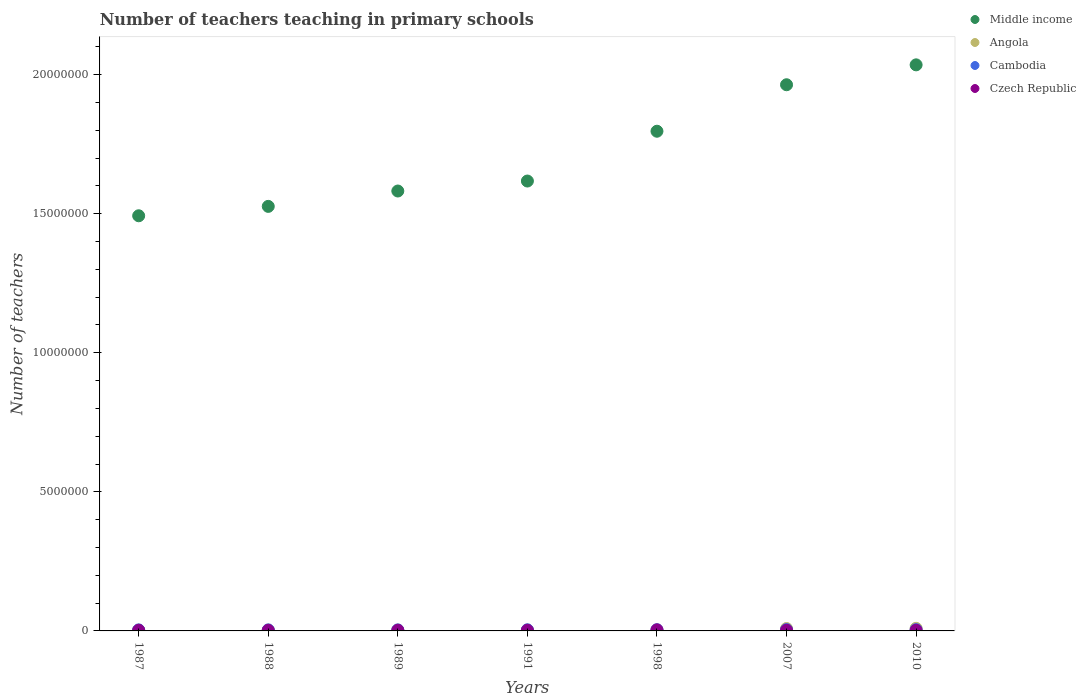How many different coloured dotlines are there?
Your response must be concise. 4. Is the number of dotlines equal to the number of legend labels?
Offer a very short reply. Yes. What is the number of teachers teaching in primary schools in Czech Republic in 1988?
Your response must be concise. 2.15e+04. Across all years, what is the maximum number of teachers teaching in primary schools in Middle income?
Give a very brief answer. 2.04e+07. Across all years, what is the minimum number of teachers teaching in primary schools in Czech Republic?
Keep it short and to the point. 2.15e+04. In which year was the number of teachers teaching in primary schools in Angola maximum?
Your answer should be compact. 2010. What is the total number of teachers teaching in primary schools in Czech Republic in the graph?
Provide a succinct answer. 1.78e+05. What is the difference between the number of teachers teaching in primary schools in Cambodia in 1989 and that in 2010?
Your response must be concise. -9975. What is the difference between the number of teachers teaching in primary schools in Middle income in 1998 and the number of teachers teaching in primary schools in Cambodia in 1988?
Offer a very short reply. 1.79e+07. What is the average number of teachers teaching in primary schools in Middle income per year?
Make the answer very short. 1.72e+07. In the year 1998, what is the difference between the number of teachers teaching in primary schools in Czech Republic and number of teachers teaching in primary schools in Angola?
Provide a succinct answer. 5618. In how many years, is the number of teachers teaching in primary schools in Middle income greater than 7000000?
Your answer should be very brief. 7. What is the ratio of the number of teachers teaching in primary schools in Cambodia in 1991 to that in 2007?
Offer a very short reply. 0.84. Is the number of teachers teaching in primary schools in Czech Republic in 1989 less than that in 1991?
Offer a terse response. Yes. What is the difference between the highest and the second highest number of teachers teaching in primary schools in Angola?
Give a very brief answer. 6965. What is the difference between the highest and the lowest number of teachers teaching in primary schools in Czech Republic?
Provide a succinct answer. 1.60e+04. In how many years, is the number of teachers teaching in primary schools in Cambodia greater than the average number of teachers teaching in primary schools in Cambodia taken over all years?
Offer a very short reply. 3. Is the sum of the number of teachers teaching in primary schools in Cambodia in 1989 and 1998 greater than the maximum number of teachers teaching in primary schools in Middle income across all years?
Provide a succinct answer. No. Is it the case that in every year, the sum of the number of teachers teaching in primary schools in Czech Republic and number of teachers teaching in primary schools in Cambodia  is greater than the sum of number of teachers teaching in primary schools in Middle income and number of teachers teaching in primary schools in Angola?
Your answer should be compact. No. How many dotlines are there?
Keep it short and to the point. 4. Are the values on the major ticks of Y-axis written in scientific E-notation?
Your answer should be compact. No. Does the graph contain any zero values?
Offer a very short reply. No. Does the graph contain grids?
Offer a terse response. No. Where does the legend appear in the graph?
Offer a terse response. Top right. How many legend labels are there?
Offer a very short reply. 4. How are the legend labels stacked?
Your response must be concise. Vertical. What is the title of the graph?
Make the answer very short. Number of teachers teaching in primary schools. What is the label or title of the Y-axis?
Offer a very short reply. Number of teachers. What is the Number of teachers in Middle income in 1987?
Offer a terse response. 1.49e+07. What is the Number of teachers in Angola in 1987?
Give a very brief answer. 3.03e+04. What is the Number of teachers of Cambodia in 1987?
Your answer should be compact. 3.68e+04. What is the Number of teachers of Czech Republic in 1987?
Your response must be concise. 2.27e+04. What is the Number of teachers in Middle income in 1988?
Give a very brief answer. 1.53e+07. What is the Number of teachers of Angola in 1988?
Your answer should be compact. 3.17e+04. What is the Number of teachers of Cambodia in 1988?
Offer a terse response. 3.73e+04. What is the Number of teachers in Czech Republic in 1988?
Offer a very short reply. 2.15e+04. What is the Number of teachers of Middle income in 1989?
Make the answer very short. 1.58e+07. What is the Number of teachers of Angola in 1989?
Your response must be concise. 3.20e+04. What is the Number of teachers of Cambodia in 1989?
Offer a very short reply. 3.69e+04. What is the Number of teachers in Czech Republic in 1989?
Give a very brief answer. 2.34e+04. What is the Number of teachers of Middle income in 1991?
Ensure brevity in your answer.  1.62e+07. What is the Number of teachers of Angola in 1991?
Your answer should be compact. 3.11e+04. What is the Number of teachers in Cambodia in 1991?
Your response must be concise. 4.08e+04. What is the Number of teachers of Czech Republic in 1991?
Provide a short and direct response. 2.36e+04. What is the Number of teachers in Middle income in 1998?
Offer a very short reply. 1.80e+07. What is the Number of teachers in Angola in 1998?
Give a very brief answer. 3.19e+04. What is the Number of teachers of Cambodia in 1998?
Your answer should be compact. 4.33e+04. What is the Number of teachers in Czech Republic in 1998?
Your answer should be compact. 3.75e+04. What is the Number of teachers of Middle income in 2007?
Ensure brevity in your answer.  1.96e+07. What is the Number of teachers in Angola in 2007?
Your answer should be compact. 8.68e+04. What is the Number of teachers of Cambodia in 2007?
Provide a short and direct response. 4.87e+04. What is the Number of teachers of Czech Republic in 2007?
Offer a very short reply. 2.47e+04. What is the Number of teachers of Middle income in 2010?
Provide a short and direct response. 2.04e+07. What is the Number of teachers in Angola in 2010?
Offer a very short reply. 9.37e+04. What is the Number of teachers in Cambodia in 2010?
Offer a very short reply. 4.69e+04. What is the Number of teachers of Czech Republic in 2010?
Ensure brevity in your answer.  2.48e+04. Across all years, what is the maximum Number of teachers of Middle income?
Provide a succinct answer. 2.04e+07. Across all years, what is the maximum Number of teachers of Angola?
Your response must be concise. 9.37e+04. Across all years, what is the maximum Number of teachers in Cambodia?
Offer a terse response. 4.87e+04. Across all years, what is the maximum Number of teachers in Czech Republic?
Provide a short and direct response. 3.75e+04. Across all years, what is the minimum Number of teachers of Middle income?
Make the answer very short. 1.49e+07. Across all years, what is the minimum Number of teachers in Angola?
Make the answer very short. 3.03e+04. Across all years, what is the minimum Number of teachers of Cambodia?
Your answer should be compact. 3.68e+04. Across all years, what is the minimum Number of teachers of Czech Republic?
Provide a succinct answer. 2.15e+04. What is the total Number of teachers of Middle income in the graph?
Make the answer very short. 1.20e+08. What is the total Number of teachers in Angola in the graph?
Provide a short and direct response. 3.37e+05. What is the total Number of teachers of Cambodia in the graph?
Offer a very short reply. 2.91e+05. What is the total Number of teachers of Czech Republic in the graph?
Provide a short and direct response. 1.78e+05. What is the difference between the Number of teachers in Middle income in 1987 and that in 1988?
Provide a succinct answer. -3.38e+05. What is the difference between the Number of teachers in Angola in 1987 and that in 1988?
Offer a very short reply. -1348. What is the difference between the Number of teachers of Cambodia in 1987 and that in 1988?
Provide a short and direct response. -538. What is the difference between the Number of teachers in Czech Republic in 1987 and that in 1988?
Offer a very short reply. 1203. What is the difference between the Number of teachers of Middle income in 1987 and that in 1989?
Offer a very short reply. -8.90e+05. What is the difference between the Number of teachers of Angola in 1987 and that in 1989?
Give a very brief answer. -1643. What is the difference between the Number of teachers in Cambodia in 1987 and that in 1989?
Your answer should be very brief. -176. What is the difference between the Number of teachers of Czech Republic in 1987 and that in 1989?
Ensure brevity in your answer.  -643. What is the difference between the Number of teachers of Middle income in 1987 and that in 1991?
Keep it short and to the point. -1.25e+06. What is the difference between the Number of teachers of Angola in 1987 and that in 1991?
Offer a terse response. -752. What is the difference between the Number of teachers in Cambodia in 1987 and that in 1991?
Offer a very short reply. -4066. What is the difference between the Number of teachers in Czech Republic in 1987 and that in 1991?
Offer a very short reply. -888. What is the difference between the Number of teachers of Middle income in 1987 and that in 1998?
Your answer should be very brief. -3.04e+06. What is the difference between the Number of teachers of Angola in 1987 and that in 1998?
Offer a terse response. -1568. What is the difference between the Number of teachers in Cambodia in 1987 and that in 1998?
Provide a short and direct response. -6528. What is the difference between the Number of teachers in Czech Republic in 1987 and that in 1998?
Provide a short and direct response. -1.48e+04. What is the difference between the Number of teachers of Middle income in 1987 and that in 2007?
Make the answer very short. -4.71e+06. What is the difference between the Number of teachers of Angola in 1987 and that in 2007?
Your answer should be compact. -5.65e+04. What is the difference between the Number of teachers of Cambodia in 1987 and that in 2007?
Offer a terse response. -1.20e+04. What is the difference between the Number of teachers of Czech Republic in 1987 and that in 2007?
Give a very brief answer. -1971. What is the difference between the Number of teachers in Middle income in 1987 and that in 2010?
Provide a succinct answer. -5.43e+06. What is the difference between the Number of teachers of Angola in 1987 and that in 2010?
Ensure brevity in your answer.  -6.34e+04. What is the difference between the Number of teachers of Cambodia in 1987 and that in 2010?
Your response must be concise. -1.02e+04. What is the difference between the Number of teachers in Czech Republic in 1987 and that in 2010?
Your answer should be very brief. -2027. What is the difference between the Number of teachers in Middle income in 1988 and that in 1989?
Offer a terse response. -5.53e+05. What is the difference between the Number of teachers in Angola in 1988 and that in 1989?
Ensure brevity in your answer.  -295. What is the difference between the Number of teachers of Cambodia in 1988 and that in 1989?
Offer a very short reply. 362. What is the difference between the Number of teachers of Czech Republic in 1988 and that in 1989?
Give a very brief answer. -1846. What is the difference between the Number of teachers of Middle income in 1988 and that in 1991?
Provide a succinct answer. -9.12e+05. What is the difference between the Number of teachers in Angola in 1988 and that in 1991?
Offer a very short reply. 596. What is the difference between the Number of teachers of Cambodia in 1988 and that in 1991?
Give a very brief answer. -3528. What is the difference between the Number of teachers in Czech Republic in 1988 and that in 1991?
Your answer should be compact. -2091. What is the difference between the Number of teachers in Middle income in 1988 and that in 1998?
Your response must be concise. -2.70e+06. What is the difference between the Number of teachers of Angola in 1988 and that in 1998?
Make the answer very short. -220. What is the difference between the Number of teachers of Cambodia in 1988 and that in 1998?
Keep it short and to the point. -5990. What is the difference between the Number of teachers of Czech Republic in 1988 and that in 1998?
Keep it short and to the point. -1.60e+04. What is the difference between the Number of teachers of Middle income in 1988 and that in 2007?
Keep it short and to the point. -4.37e+06. What is the difference between the Number of teachers in Angola in 1988 and that in 2007?
Your response must be concise. -5.51e+04. What is the difference between the Number of teachers in Cambodia in 1988 and that in 2007?
Your answer should be very brief. -1.14e+04. What is the difference between the Number of teachers of Czech Republic in 1988 and that in 2007?
Offer a terse response. -3174. What is the difference between the Number of teachers in Middle income in 1988 and that in 2010?
Keep it short and to the point. -5.09e+06. What is the difference between the Number of teachers in Angola in 1988 and that in 2010?
Your response must be concise. -6.21e+04. What is the difference between the Number of teachers of Cambodia in 1988 and that in 2010?
Ensure brevity in your answer.  -9613. What is the difference between the Number of teachers in Czech Republic in 1988 and that in 2010?
Make the answer very short. -3230. What is the difference between the Number of teachers of Middle income in 1989 and that in 1991?
Provide a succinct answer. -3.59e+05. What is the difference between the Number of teachers of Angola in 1989 and that in 1991?
Keep it short and to the point. 891. What is the difference between the Number of teachers of Cambodia in 1989 and that in 1991?
Keep it short and to the point. -3890. What is the difference between the Number of teachers of Czech Republic in 1989 and that in 1991?
Your answer should be compact. -245. What is the difference between the Number of teachers of Middle income in 1989 and that in 1998?
Provide a succinct answer. -2.15e+06. What is the difference between the Number of teachers of Angola in 1989 and that in 1998?
Keep it short and to the point. 75. What is the difference between the Number of teachers of Cambodia in 1989 and that in 1998?
Keep it short and to the point. -6352. What is the difference between the Number of teachers of Czech Republic in 1989 and that in 1998?
Offer a very short reply. -1.41e+04. What is the difference between the Number of teachers of Middle income in 1989 and that in 2007?
Offer a very short reply. -3.82e+06. What is the difference between the Number of teachers in Angola in 1989 and that in 2007?
Give a very brief answer. -5.48e+04. What is the difference between the Number of teachers of Cambodia in 1989 and that in 2007?
Provide a short and direct response. -1.18e+04. What is the difference between the Number of teachers of Czech Republic in 1989 and that in 2007?
Offer a very short reply. -1328. What is the difference between the Number of teachers in Middle income in 1989 and that in 2010?
Give a very brief answer. -4.54e+06. What is the difference between the Number of teachers of Angola in 1989 and that in 2010?
Your answer should be compact. -6.18e+04. What is the difference between the Number of teachers of Cambodia in 1989 and that in 2010?
Ensure brevity in your answer.  -9975. What is the difference between the Number of teachers of Czech Republic in 1989 and that in 2010?
Keep it short and to the point. -1384. What is the difference between the Number of teachers in Middle income in 1991 and that in 1998?
Provide a succinct answer. -1.79e+06. What is the difference between the Number of teachers in Angola in 1991 and that in 1998?
Give a very brief answer. -816. What is the difference between the Number of teachers in Cambodia in 1991 and that in 1998?
Your answer should be compact. -2462. What is the difference between the Number of teachers in Czech Republic in 1991 and that in 1998?
Your answer should be very brief. -1.39e+04. What is the difference between the Number of teachers in Middle income in 1991 and that in 2007?
Your answer should be compact. -3.46e+06. What is the difference between the Number of teachers in Angola in 1991 and that in 2007?
Your answer should be very brief. -5.57e+04. What is the difference between the Number of teachers in Cambodia in 1991 and that in 2007?
Ensure brevity in your answer.  -7916. What is the difference between the Number of teachers in Czech Republic in 1991 and that in 2007?
Your answer should be very brief. -1083. What is the difference between the Number of teachers of Middle income in 1991 and that in 2010?
Ensure brevity in your answer.  -4.18e+06. What is the difference between the Number of teachers in Angola in 1991 and that in 2010?
Your response must be concise. -6.27e+04. What is the difference between the Number of teachers of Cambodia in 1991 and that in 2010?
Your response must be concise. -6085. What is the difference between the Number of teachers of Czech Republic in 1991 and that in 2010?
Your answer should be very brief. -1139. What is the difference between the Number of teachers in Middle income in 1998 and that in 2007?
Your answer should be compact. -1.67e+06. What is the difference between the Number of teachers of Angola in 1998 and that in 2007?
Offer a very short reply. -5.49e+04. What is the difference between the Number of teachers in Cambodia in 1998 and that in 2007?
Make the answer very short. -5454. What is the difference between the Number of teachers of Czech Republic in 1998 and that in 2007?
Your response must be concise. 1.28e+04. What is the difference between the Number of teachers of Middle income in 1998 and that in 2010?
Keep it short and to the point. -2.39e+06. What is the difference between the Number of teachers in Angola in 1998 and that in 2010?
Ensure brevity in your answer.  -6.19e+04. What is the difference between the Number of teachers in Cambodia in 1998 and that in 2010?
Provide a succinct answer. -3623. What is the difference between the Number of teachers of Czech Republic in 1998 and that in 2010?
Ensure brevity in your answer.  1.27e+04. What is the difference between the Number of teachers of Middle income in 2007 and that in 2010?
Ensure brevity in your answer.  -7.15e+05. What is the difference between the Number of teachers in Angola in 2007 and that in 2010?
Provide a short and direct response. -6965. What is the difference between the Number of teachers of Cambodia in 2007 and that in 2010?
Your answer should be very brief. 1831. What is the difference between the Number of teachers in Czech Republic in 2007 and that in 2010?
Provide a succinct answer. -56. What is the difference between the Number of teachers in Middle income in 1987 and the Number of teachers in Angola in 1988?
Your answer should be very brief. 1.49e+07. What is the difference between the Number of teachers of Middle income in 1987 and the Number of teachers of Cambodia in 1988?
Give a very brief answer. 1.49e+07. What is the difference between the Number of teachers in Middle income in 1987 and the Number of teachers in Czech Republic in 1988?
Provide a succinct answer. 1.49e+07. What is the difference between the Number of teachers of Angola in 1987 and the Number of teachers of Cambodia in 1988?
Your answer should be compact. -6982. What is the difference between the Number of teachers of Angola in 1987 and the Number of teachers of Czech Republic in 1988?
Provide a short and direct response. 8771. What is the difference between the Number of teachers in Cambodia in 1987 and the Number of teachers in Czech Republic in 1988?
Offer a terse response. 1.52e+04. What is the difference between the Number of teachers of Middle income in 1987 and the Number of teachers of Angola in 1989?
Provide a short and direct response. 1.49e+07. What is the difference between the Number of teachers of Middle income in 1987 and the Number of teachers of Cambodia in 1989?
Your answer should be compact. 1.49e+07. What is the difference between the Number of teachers of Middle income in 1987 and the Number of teachers of Czech Republic in 1989?
Your answer should be compact. 1.49e+07. What is the difference between the Number of teachers of Angola in 1987 and the Number of teachers of Cambodia in 1989?
Your response must be concise. -6620. What is the difference between the Number of teachers of Angola in 1987 and the Number of teachers of Czech Republic in 1989?
Keep it short and to the point. 6925. What is the difference between the Number of teachers in Cambodia in 1987 and the Number of teachers in Czech Republic in 1989?
Offer a terse response. 1.34e+04. What is the difference between the Number of teachers of Middle income in 1987 and the Number of teachers of Angola in 1991?
Make the answer very short. 1.49e+07. What is the difference between the Number of teachers in Middle income in 1987 and the Number of teachers in Cambodia in 1991?
Provide a succinct answer. 1.49e+07. What is the difference between the Number of teachers of Middle income in 1987 and the Number of teachers of Czech Republic in 1991?
Provide a succinct answer. 1.49e+07. What is the difference between the Number of teachers of Angola in 1987 and the Number of teachers of Cambodia in 1991?
Your answer should be compact. -1.05e+04. What is the difference between the Number of teachers in Angola in 1987 and the Number of teachers in Czech Republic in 1991?
Ensure brevity in your answer.  6680. What is the difference between the Number of teachers in Cambodia in 1987 and the Number of teachers in Czech Republic in 1991?
Offer a terse response. 1.31e+04. What is the difference between the Number of teachers of Middle income in 1987 and the Number of teachers of Angola in 1998?
Your answer should be compact. 1.49e+07. What is the difference between the Number of teachers in Middle income in 1987 and the Number of teachers in Cambodia in 1998?
Provide a succinct answer. 1.49e+07. What is the difference between the Number of teachers of Middle income in 1987 and the Number of teachers of Czech Republic in 1998?
Your answer should be very brief. 1.49e+07. What is the difference between the Number of teachers in Angola in 1987 and the Number of teachers in Cambodia in 1998?
Provide a short and direct response. -1.30e+04. What is the difference between the Number of teachers of Angola in 1987 and the Number of teachers of Czech Republic in 1998?
Ensure brevity in your answer.  -7186. What is the difference between the Number of teachers in Cambodia in 1987 and the Number of teachers in Czech Republic in 1998?
Give a very brief answer. -742. What is the difference between the Number of teachers of Middle income in 1987 and the Number of teachers of Angola in 2007?
Your answer should be compact. 1.48e+07. What is the difference between the Number of teachers in Middle income in 1987 and the Number of teachers in Cambodia in 2007?
Ensure brevity in your answer.  1.49e+07. What is the difference between the Number of teachers in Middle income in 1987 and the Number of teachers in Czech Republic in 2007?
Keep it short and to the point. 1.49e+07. What is the difference between the Number of teachers in Angola in 1987 and the Number of teachers in Cambodia in 2007?
Provide a short and direct response. -1.84e+04. What is the difference between the Number of teachers of Angola in 1987 and the Number of teachers of Czech Republic in 2007?
Offer a terse response. 5597. What is the difference between the Number of teachers in Cambodia in 1987 and the Number of teachers in Czech Republic in 2007?
Provide a succinct answer. 1.20e+04. What is the difference between the Number of teachers in Middle income in 1987 and the Number of teachers in Angola in 2010?
Offer a very short reply. 1.48e+07. What is the difference between the Number of teachers in Middle income in 1987 and the Number of teachers in Cambodia in 2010?
Give a very brief answer. 1.49e+07. What is the difference between the Number of teachers in Middle income in 1987 and the Number of teachers in Czech Republic in 2010?
Make the answer very short. 1.49e+07. What is the difference between the Number of teachers in Angola in 1987 and the Number of teachers in Cambodia in 2010?
Your answer should be very brief. -1.66e+04. What is the difference between the Number of teachers in Angola in 1987 and the Number of teachers in Czech Republic in 2010?
Offer a terse response. 5541. What is the difference between the Number of teachers of Cambodia in 1987 and the Number of teachers of Czech Republic in 2010?
Make the answer very short. 1.20e+04. What is the difference between the Number of teachers of Middle income in 1988 and the Number of teachers of Angola in 1989?
Offer a terse response. 1.52e+07. What is the difference between the Number of teachers of Middle income in 1988 and the Number of teachers of Cambodia in 1989?
Your answer should be compact. 1.52e+07. What is the difference between the Number of teachers in Middle income in 1988 and the Number of teachers in Czech Republic in 1989?
Your answer should be very brief. 1.52e+07. What is the difference between the Number of teachers in Angola in 1988 and the Number of teachers in Cambodia in 1989?
Your answer should be compact. -5272. What is the difference between the Number of teachers in Angola in 1988 and the Number of teachers in Czech Republic in 1989?
Your response must be concise. 8273. What is the difference between the Number of teachers of Cambodia in 1988 and the Number of teachers of Czech Republic in 1989?
Your response must be concise. 1.39e+04. What is the difference between the Number of teachers in Middle income in 1988 and the Number of teachers in Angola in 1991?
Keep it short and to the point. 1.52e+07. What is the difference between the Number of teachers of Middle income in 1988 and the Number of teachers of Cambodia in 1991?
Offer a terse response. 1.52e+07. What is the difference between the Number of teachers in Middle income in 1988 and the Number of teachers in Czech Republic in 1991?
Give a very brief answer. 1.52e+07. What is the difference between the Number of teachers of Angola in 1988 and the Number of teachers of Cambodia in 1991?
Make the answer very short. -9162. What is the difference between the Number of teachers of Angola in 1988 and the Number of teachers of Czech Republic in 1991?
Offer a terse response. 8028. What is the difference between the Number of teachers in Cambodia in 1988 and the Number of teachers in Czech Republic in 1991?
Keep it short and to the point. 1.37e+04. What is the difference between the Number of teachers in Middle income in 1988 and the Number of teachers in Angola in 1998?
Your answer should be very brief. 1.52e+07. What is the difference between the Number of teachers in Middle income in 1988 and the Number of teachers in Cambodia in 1998?
Your answer should be very brief. 1.52e+07. What is the difference between the Number of teachers of Middle income in 1988 and the Number of teachers of Czech Republic in 1998?
Provide a succinct answer. 1.52e+07. What is the difference between the Number of teachers of Angola in 1988 and the Number of teachers of Cambodia in 1998?
Your answer should be very brief. -1.16e+04. What is the difference between the Number of teachers of Angola in 1988 and the Number of teachers of Czech Republic in 1998?
Ensure brevity in your answer.  -5838. What is the difference between the Number of teachers of Cambodia in 1988 and the Number of teachers of Czech Republic in 1998?
Ensure brevity in your answer.  -204. What is the difference between the Number of teachers of Middle income in 1988 and the Number of teachers of Angola in 2007?
Provide a succinct answer. 1.52e+07. What is the difference between the Number of teachers of Middle income in 1988 and the Number of teachers of Cambodia in 2007?
Keep it short and to the point. 1.52e+07. What is the difference between the Number of teachers of Middle income in 1988 and the Number of teachers of Czech Republic in 2007?
Your answer should be compact. 1.52e+07. What is the difference between the Number of teachers of Angola in 1988 and the Number of teachers of Cambodia in 2007?
Give a very brief answer. -1.71e+04. What is the difference between the Number of teachers in Angola in 1988 and the Number of teachers in Czech Republic in 2007?
Your answer should be very brief. 6945. What is the difference between the Number of teachers of Cambodia in 1988 and the Number of teachers of Czech Republic in 2007?
Provide a short and direct response. 1.26e+04. What is the difference between the Number of teachers in Middle income in 1988 and the Number of teachers in Angola in 2010?
Your response must be concise. 1.52e+07. What is the difference between the Number of teachers of Middle income in 1988 and the Number of teachers of Cambodia in 2010?
Your answer should be compact. 1.52e+07. What is the difference between the Number of teachers of Middle income in 1988 and the Number of teachers of Czech Republic in 2010?
Give a very brief answer. 1.52e+07. What is the difference between the Number of teachers in Angola in 1988 and the Number of teachers in Cambodia in 2010?
Provide a succinct answer. -1.52e+04. What is the difference between the Number of teachers in Angola in 1988 and the Number of teachers in Czech Republic in 2010?
Offer a terse response. 6889. What is the difference between the Number of teachers of Cambodia in 1988 and the Number of teachers of Czech Republic in 2010?
Offer a terse response. 1.25e+04. What is the difference between the Number of teachers of Middle income in 1989 and the Number of teachers of Angola in 1991?
Offer a terse response. 1.58e+07. What is the difference between the Number of teachers of Middle income in 1989 and the Number of teachers of Cambodia in 1991?
Provide a short and direct response. 1.58e+07. What is the difference between the Number of teachers of Middle income in 1989 and the Number of teachers of Czech Republic in 1991?
Keep it short and to the point. 1.58e+07. What is the difference between the Number of teachers of Angola in 1989 and the Number of teachers of Cambodia in 1991?
Your response must be concise. -8867. What is the difference between the Number of teachers in Angola in 1989 and the Number of teachers in Czech Republic in 1991?
Offer a terse response. 8323. What is the difference between the Number of teachers in Cambodia in 1989 and the Number of teachers in Czech Republic in 1991?
Offer a terse response. 1.33e+04. What is the difference between the Number of teachers in Middle income in 1989 and the Number of teachers in Angola in 1998?
Provide a succinct answer. 1.58e+07. What is the difference between the Number of teachers in Middle income in 1989 and the Number of teachers in Cambodia in 1998?
Give a very brief answer. 1.58e+07. What is the difference between the Number of teachers in Middle income in 1989 and the Number of teachers in Czech Republic in 1998?
Your response must be concise. 1.58e+07. What is the difference between the Number of teachers of Angola in 1989 and the Number of teachers of Cambodia in 1998?
Keep it short and to the point. -1.13e+04. What is the difference between the Number of teachers of Angola in 1989 and the Number of teachers of Czech Republic in 1998?
Offer a terse response. -5543. What is the difference between the Number of teachers of Cambodia in 1989 and the Number of teachers of Czech Republic in 1998?
Provide a succinct answer. -566. What is the difference between the Number of teachers in Middle income in 1989 and the Number of teachers in Angola in 2007?
Make the answer very short. 1.57e+07. What is the difference between the Number of teachers in Middle income in 1989 and the Number of teachers in Cambodia in 2007?
Offer a very short reply. 1.58e+07. What is the difference between the Number of teachers of Middle income in 1989 and the Number of teachers of Czech Republic in 2007?
Offer a very short reply. 1.58e+07. What is the difference between the Number of teachers of Angola in 1989 and the Number of teachers of Cambodia in 2007?
Ensure brevity in your answer.  -1.68e+04. What is the difference between the Number of teachers of Angola in 1989 and the Number of teachers of Czech Republic in 2007?
Your answer should be very brief. 7240. What is the difference between the Number of teachers in Cambodia in 1989 and the Number of teachers in Czech Republic in 2007?
Keep it short and to the point. 1.22e+04. What is the difference between the Number of teachers in Middle income in 1989 and the Number of teachers in Angola in 2010?
Give a very brief answer. 1.57e+07. What is the difference between the Number of teachers in Middle income in 1989 and the Number of teachers in Cambodia in 2010?
Keep it short and to the point. 1.58e+07. What is the difference between the Number of teachers of Middle income in 1989 and the Number of teachers of Czech Republic in 2010?
Give a very brief answer. 1.58e+07. What is the difference between the Number of teachers in Angola in 1989 and the Number of teachers in Cambodia in 2010?
Offer a terse response. -1.50e+04. What is the difference between the Number of teachers in Angola in 1989 and the Number of teachers in Czech Republic in 2010?
Ensure brevity in your answer.  7184. What is the difference between the Number of teachers in Cambodia in 1989 and the Number of teachers in Czech Republic in 2010?
Offer a terse response. 1.22e+04. What is the difference between the Number of teachers in Middle income in 1991 and the Number of teachers in Angola in 1998?
Offer a terse response. 1.61e+07. What is the difference between the Number of teachers in Middle income in 1991 and the Number of teachers in Cambodia in 1998?
Provide a succinct answer. 1.61e+07. What is the difference between the Number of teachers in Middle income in 1991 and the Number of teachers in Czech Republic in 1998?
Ensure brevity in your answer.  1.61e+07. What is the difference between the Number of teachers of Angola in 1991 and the Number of teachers of Cambodia in 1998?
Your answer should be compact. -1.22e+04. What is the difference between the Number of teachers in Angola in 1991 and the Number of teachers in Czech Republic in 1998?
Offer a very short reply. -6434. What is the difference between the Number of teachers in Cambodia in 1991 and the Number of teachers in Czech Republic in 1998?
Give a very brief answer. 3324. What is the difference between the Number of teachers in Middle income in 1991 and the Number of teachers in Angola in 2007?
Your response must be concise. 1.61e+07. What is the difference between the Number of teachers of Middle income in 1991 and the Number of teachers of Cambodia in 2007?
Make the answer very short. 1.61e+07. What is the difference between the Number of teachers of Middle income in 1991 and the Number of teachers of Czech Republic in 2007?
Provide a short and direct response. 1.61e+07. What is the difference between the Number of teachers of Angola in 1991 and the Number of teachers of Cambodia in 2007?
Keep it short and to the point. -1.77e+04. What is the difference between the Number of teachers of Angola in 1991 and the Number of teachers of Czech Republic in 2007?
Your answer should be compact. 6349. What is the difference between the Number of teachers of Cambodia in 1991 and the Number of teachers of Czech Republic in 2007?
Provide a succinct answer. 1.61e+04. What is the difference between the Number of teachers in Middle income in 1991 and the Number of teachers in Angola in 2010?
Offer a terse response. 1.61e+07. What is the difference between the Number of teachers of Middle income in 1991 and the Number of teachers of Cambodia in 2010?
Provide a succinct answer. 1.61e+07. What is the difference between the Number of teachers in Middle income in 1991 and the Number of teachers in Czech Republic in 2010?
Provide a short and direct response. 1.61e+07. What is the difference between the Number of teachers in Angola in 1991 and the Number of teachers in Cambodia in 2010?
Give a very brief answer. -1.58e+04. What is the difference between the Number of teachers in Angola in 1991 and the Number of teachers in Czech Republic in 2010?
Give a very brief answer. 6293. What is the difference between the Number of teachers of Cambodia in 1991 and the Number of teachers of Czech Republic in 2010?
Ensure brevity in your answer.  1.61e+04. What is the difference between the Number of teachers in Middle income in 1998 and the Number of teachers in Angola in 2007?
Keep it short and to the point. 1.79e+07. What is the difference between the Number of teachers of Middle income in 1998 and the Number of teachers of Cambodia in 2007?
Offer a terse response. 1.79e+07. What is the difference between the Number of teachers of Middle income in 1998 and the Number of teachers of Czech Republic in 2007?
Give a very brief answer. 1.79e+07. What is the difference between the Number of teachers of Angola in 1998 and the Number of teachers of Cambodia in 2007?
Your response must be concise. -1.69e+04. What is the difference between the Number of teachers of Angola in 1998 and the Number of teachers of Czech Republic in 2007?
Your answer should be very brief. 7165. What is the difference between the Number of teachers in Cambodia in 1998 and the Number of teachers in Czech Republic in 2007?
Offer a very short reply. 1.86e+04. What is the difference between the Number of teachers of Middle income in 1998 and the Number of teachers of Angola in 2010?
Offer a terse response. 1.79e+07. What is the difference between the Number of teachers of Middle income in 1998 and the Number of teachers of Cambodia in 2010?
Ensure brevity in your answer.  1.79e+07. What is the difference between the Number of teachers of Middle income in 1998 and the Number of teachers of Czech Republic in 2010?
Give a very brief answer. 1.79e+07. What is the difference between the Number of teachers of Angola in 1998 and the Number of teachers of Cambodia in 2010?
Offer a very short reply. -1.50e+04. What is the difference between the Number of teachers of Angola in 1998 and the Number of teachers of Czech Republic in 2010?
Ensure brevity in your answer.  7109. What is the difference between the Number of teachers in Cambodia in 1998 and the Number of teachers in Czech Republic in 2010?
Offer a terse response. 1.85e+04. What is the difference between the Number of teachers of Middle income in 2007 and the Number of teachers of Angola in 2010?
Make the answer very short. 1.95e+07. What is the difference between the Number of teachers of Middle income in 2007 and the Number of teachers of Cambodia in 2010?
Ensure brevity in your answer.  1.96e+07. What is the difference between the Number of teachers of Middle income in 2007 and the Number of teachers of Czech Republic in 2010?
Provide a succinct answer. 1.96e+07. What is the difference between the Number of teachers in Angola in 2007 and the Number of teachers in Cambodia in 2010?
Provide a short and direct response. 3.99e+04. What is the difference between the Number of teachers of Angola in 2007 and the Number of teachers of Czech Republic in 2010?
Your answer should be very brief. 6.20e+04. What is the difference between the Number of teachers of Cambodia in 2007 and the Number of teachers of Czech Republic in 2010?
Give a very brief answer. 2.40e+04. What is the average Number of teachers of Middle income per year?
Give a very brief answer. 1.72e+07. What is the average Number of teachers of Angola per year?
Give a very brief answer. 4.82e+04. What is the average Number of teachers in Cambodia per year?
Make the answer very short. 4.15e+04. What is the average Number of teachers in Czech Republic per year?
Ensure brevity in your answer.  2.55e+04. In the year 1987, what is the difference between the Number of teachers of Middle income and Number of teachers of Angola?
Make the answer very short. 1.49e+07. In the year 1987, what is the difference between the Number of teachers in Middle income and Number of teachers in Cambodia?
Your answer should be compact. 1.49e+07. In the year 1987, what is the difference between the Number of teachers of Middle income and Number of teachers of Czech Republic?
Offer a very short reply. 1.49e+07. In the year 1987, what is the difference between the Number of teachers in Angola and Number of teachers in Cambodia?
Your answer should be compact. -6444. In the year 1987, what is the difference between the Number of teachers in Angola and Number of teachers in Czech Republic?
Offer a terse response. 7568. In the year 1987, what is the difference between the Number of teachers in Cambodia and Number of teachers in Czech Republic?
Your answer should be very brief. 1.40e+04. In the year 1988, what is the difference between the Number of teachers in Middle income and Number of teachers in Angola?
Your answer should be very brief. 1.52e+07. In the year 1988, what is the difference between the Number of teachers in Middle income and Number of teachers in Cambodia?
Keep it short and to the point. 1.52e+07. In the year 1988, what is the difference between the Number of teachers of Middle income and Number of teachers of Czech Republic?
Ensure brevity in your answer.  1.52e+07. In the year 1988, what is the difference between the Number of teachers of Angola and Number of teachers of Cambodia?
Offer a very short reply. -5634. In the year 1988, what is the difference between the Number of teachers of Angola and Number of teachers of Czech Republic?
Ensure brevity in your answer.  1.01e+04. In the year 1988, what is the difference between the Number of teachers in Cambodia and Number of teachers in Czech Republic?
Offer a terse response. 1.58e+04. In the year 1989, what is the difference between the Number of teachers of Middle income and Number of teachers of Angola?
Your answer should be compact. 1.58e+07. In the year 1989, what is the difference between the Number of teachers of Middle income and Number of teachers of Cambodia?
Provide a short and direct response. 1.58e+07. In the year 1989, what is the difference between the Number of teachers in Middle income and Number of teachers in Czech Republic?
Provide a short and direct response. 1.58e+07. In the year 1989, what is the difference between the Number of teachers in Angola and Number of teachers in Cambodia?
Give a very brief answer. -4977. In the year 1989, what is the difference between the Number of teachers of Angola and Number of teachers of Czech Republic?
Your response must be concise. 8568. In the year 1989, what is the difference between the Number of teachers in Cambodia and Number of teachers in Czech Republic?
Provide a short and direct response. 1.35e+04. In the year 1991, what is the difference between the Number of teachers in Middle income and Number of teachers in Angola?
Give a very brief answer. 1.61e+07. In the year 1991, what is the difference between the Number of teachers of Middle income and Number of teachers of Cambodia?
Provide a succinct answer. 1.61e+07. In the year 1991, what is the difference between the Number of teachers in Middle income and Number of teachers in Czech Republic?
Your answer should be compact. 1.62e+07. In the year 1991, what is the difference between the Number of teachers of Angola and Number of teachers of Cambodia?
Give a very brief answer. -9758. In the year 1991, what is the difference between the Number of teachers in Angola and Number of teachers in Czech Republic?
Provide a short and direct response. 7432. In the year 1991, what is the difference between the Number of teachers of Cambodia and Number of teachers of Czech Republic?
Give a very brief answer. 1.72e+04. In the year 1998, what is the difference between the Number of teachers of Middle income and Number of teachers of Angola?
Your answer should be very brief. 1.79e+07. In the year 1998, what is the difference between the Number of teachers in Middle income and Number of teachers in Cambodia?
Give a very brief answer. 1.79e+07. In the year 1998, what is the difference between the Number of teachers in Middle income and Number of teachers in Czech Republic?
Ensure brevity in your answer.  1.79e+07. In the year 1998, what is the difference between the Number of teachers of Angola and Number of teachers of Cambodia?
Make the answer very short. -1.14e+04. In the year 1998, what is the difference between the Number of teachers in Angola and Number of teachers in Czech Republic?
Offer a terse response. -5618. In the year 1998, what is the difference between the Number of teachers of Cambodia and Number of teachers of Czech Republic?
Offer a very short reply. 5786. In the year 2007, what is the difference between the Number of teachers in Middle income and Number of teachers in Angola?
Give a very brief answer. 1.95e+07. In the year 2007, what is the difference between the Number of teachers in Middle income and Number of teachers in Cambodia?
Your response must be concise. 1.96e+07. In the year 2007, what is the difference between the Number of teachers of Middle income and Number of teachers of Czech Republic?
Make the answer very short. 1.96e+07. In the year 2007, what is the difference between the Number of teachers of Angola and Number of teachers of Cambodia?
Ensure brevity in your answer.  3.80e+04. In the year 2007, what is the difference between the Number of teachers of Angola and Number of teachers of Czech Republic?
Provide a short and direct response. 6.21e+04. In the year 2007, what is the difference between the Number of teachers in Cambodia and Number of teachers in Czech Republic?
Ensure brevity in your answer.  2.40e+04. In the year 2010, what is the difference between the Number of teachers in Middle income and Number of teachers in Angola?
Provide a short and direct response. 2.03e+07. In the year 2010, what is the difference between the Number of teachers of Middle income and Number of teachers of Cambodia?
Offer a terse response. 2.03e+07. In the year 2010, what is the difference between the Number of teachers of Middle income and Number of teachers of Czech Republic?
Offer a very short reply. 2.03e+07. In the year 2010, what is the difference between the Number of teachers in Angola and Number of teachers in Cambodia?
Your answer should be very brief. 4.68e+04. In the year 2010, what is the difference between the Number of teachers in Angola and Number of teachers in Czech Republic?
Your response must be concise. 6.90e+04. In the year 2010, what is the difference between the Number of teachers in Cambodia and Number of teachers in Czech Republic?
Provide a short and direct response. 2.21e+04. What is the ratio of the Number of teachers in Middle income in 1987 to that in 1988?
Make the answer very short. 0.98. What is the ratio of the Number of teachers of Angola in 1987 to that in 1988?
Keep it short and to the point. 0.96. What is the ratio of the Number of teachers of Cambodia in 1987 to that in 1988?
Keep it short and to the point. 0.99. What is the ratio of the Number of teachers in Czech Republic in 1987 to that in 1988?
Provide a succinct answer. 1.06. What is the ratio of the Number of teachers in Middle income in 1987 to that in 1989?
Keep it short and to the point. 0.94. What is the ratio of the Number of teachers in Angola in 1987 to that in 1989?
Offer a terse response. 0.95. What is the ratio of the Number of teachers in Czech Republic in 1987 to that in 1989?
Provide a succinct answer. 0.97. What is the ratio of the Number of teachers of Middle income in 1987 to that in 1991?
Ensure brevity in your answer.  0.92. What is the ratio of the Number of teachers in Angola in 1987 to that in 1991?
Your response must be concise. 0.98. What is the ratio of the Number of teachers of Cambodia in 1987 to that in 1991?
Provide a short and direct response. 0.9. What is the ratio of the Number of teachers of Czech Republic in 1987 to that in 1991?
Provide a short and direct response. 0.96. What is the ratio of the Number of teachers in Middle income in 1987 to that in 1998?
Provide a short and direct response. 0.83. What is the ratio of the Number of teachers in Angola in 1987 to that in 1998?
Give a very brief answer. 0.95. What is the ratio of the Number of teachers in Cambodia in 1987 to that in 1998?
Offer a terse response. 0.85. What is the ratio of the Number of teachers of Czech Republic in 1987 to that in 1998?
Offer a very short reply. 0.61. What is the ratio of the Number of teachers in Middle income in 1987 to that in 2007?
Offer a very short reply. 0.76. What is the ratio of the Number of teachers in Angola in 1987 to that in 2007?
Keep it short and to the point. 0.35. What is the ratio of the Number of teachers in Cambodia in 1987 to that in 2007?
Your answer should be very brief. 0.75. What is the ratio of the Number of teachers in Czech Republic in 1987 to that in 2007?
Your response must be concise. 0.92. What is the ratio of the Number of teachers of Middle income in 1987 to that in 2010?
Make the answer very short. 0.73. What is the ratio of the Number of teachers of Angola in 1987 to that in 2010?
Your response must be concise. 0.32. What is the ratio of the Number of teachers in Cambodia in 1987 to that in 2010?
Give a very brief answer. 0.78. What is the ratio of the Number of teachers of Czech Republic in 1987 to that in 2010?
Give a very brief answer. 0.92. What is the ratio of the Number of teachers of Middle income in 1988 to that in 1989?
Your answer should be very brief. 0.97. What is the ratio of the Number of teachers in Cambodia in 1988 to that in 1989?
Offer a very short reply. 1.01. What is the ratio of the Number of teachers of Czech Republic in 1988 to that in 1989?
Keep it short and to the point. 0.92. What is the ratio of the Number of teachers in Middle income in 1988 to that in 1991?
Make the answer very short. 0.94. What is the ratio of the Number of teachers in Angola in 1988 to that in 1991?
Ensure brevity in your answer.  1.02. What is the ratio of the Number of teachers of Cambodia in 1988 to that in 1991?
Make the answer very short. 0.91. What is the ratio of the Number of teachers of Czech Republic in 1988 to that in 1991?
Offer a very short reply. 0.91. What is the ratio of the Number of teachers in Middle income in 1988 to that in 1998?
Provide a succinct answer. 0.85. What is the ratio of the Number of teachers in Angola in 1988 to that in 1998?
Provide a succinct answer. 0.99. What is the ratio of the Number of teachers in Cambodia in 1988 to that in 1998?
Provide a succinct answer. 0.86. What is the ratio of the Number of teachers in Czech Republic in 1988 to that in 1998?
Keep it short and to the point. 0.57. What is the ratio of the Number of teachers of Middle income in 1988 to that in 2007?
Your answer should be very brief. 0.78. What is the ratio of the Number of teachers of Angola in 1988 to that in 2007?
Give a very brief answer. 0.36. What is the ratio of the Number of teachers of Cambodia in 1988 to that in 2007?
Ensure brevity in your answer.  0.77. What is the ratio of the Number of teachers of Czech Republic in 1988 to that in 2007?
Your answer should be compact. 0.87. What is the ratio of the Number of teachers in Angola in 1988 to that in 2010?
Offer a terse response. 0.34. What is the ratio of the Number of teachers of Cambodia in 1988 to that in 2010?
Provide a succinct answer. 0.8. What is the ratio of the Number of teachers of Czech Republic in 1988 to that in 2010?
Your response must be concise. 0.87. What is the ratio of the Number of teachers in Middle income in 1989 to that in 1991?
Provide a succinct answer. 0.98. What is the ratio of the Number of teachers of Angola in 1989 to that in 1991?
Your answer should be very brief. 1.03. What is the ratio of the Number of teachers of Cambodia in 1989 to that in 1991?
Provide a succinct answer. 0.9. What is the ratio of the Number of teachers of Middle income in 1989 to that in 1998?
Ensure brevity in your answer.  0.88. What is the ratio of the Number of teachers in Angola in 1989 to that in 1998?
Your response must be concise. 1. What is the ratio of the Number of teachers of Cambodia in 1989 to that in 1998?
Provide a succinct answer. 0.85. What is the ratio of the Number of teachers of Czech Republic in 1989 to that in 1998?
Your response must be concise. 0.62. What is the ratio of the Number of teachers of Middle income in 1989 to that in 2007?
Give a very brief answer. 0.81. What is the ratio of the Number of teachers in Angola in 1989 to that in 2007?
Provide a succinct answer. 0.37. What is the ratio of the Number of teachers of Cambodia in 1989 to that in 2007?
Provide a short and direct response. 0.76. What is the ratio of the Number of teachers in Czech Republic in 1989 to that in 2007?
Provide a short and direct response. 0.95. What is the ratio of the Number of teachers of Middle income in 1989 to that in 2010?
Give a very brief answer. 0.78. What is the ratio of the Number of teachers in Angola in 1989 to that in 2010?
Ensure brevity in your answer.  0.34. What is the ratio of the Number of teachers in Cambodia in 1989 to that in 2010?
Offer a very short reply. 0.79. What is the ratio of the Number of teachers of Czech Republic in 1989 to that in 2010?
Your answer should be very brief. 0.94. What is the ratio of the Number of teachers of Middle income in 1991 to that in 1998?
Provide a succinct answer. 0.9. What is the ratio of the Number of teachers of Angola in 1991 to that in 1998?
Your answer should be very brief. 0.97. What is the ratio of the Number of teachers in Cambodia in 1991 to that in 1998?
Your response must be concise. 0.94. What is the ratio of the Number of teachers of Czech Republic in 1991 to that in 1998?
Your answer should be compact. 0.63. What is the ratio of the Number of teachers in Middle income in 1991 to that in 2007?
Make the answer very short. 0.82. What is the ratio of the Number of teachers in Angola in 1991 to that in 2007?
Keep it short and to the point. 0.36. What is the ratio of the Number of teachers in Cambodia in 1991 to that in 2007?
Provide a succinct answer. 0.84. What is the ratio of the Number of teachers in Czech Republic in 1991 to that in 2007?
Ensure brevity in your answer.  0.96. What is the ratio of the Number of teachers in Middle income in 1991 to that in 2010?
Your answer should be compact. 0.79. What is the ratio of the Number of teachers of Angola in 1991 to that in 2010?
Keep it short and to the point. 0.33. What is the ratio of the Number of teachers in Cambodia in 1991 to that in 2010?
Your answer should be compact. 0.87. What is the ratio of the Number of teachers of Czech Republic in 1991 to that in 2010?
Ensure brevity in your answer.  0.95. What is the ratio of the Number of teachers of Middle income in 1998 to that in 2007?
Make the answer very short. 0.91. What is the ratio of the Number of teachers of Angola in 1998 to that in 2007?
Your response must be concise. 0.37. What is the ratio of the Number of teachers in Cambodia in 1998 to that in 2007?
Provide a short and direct response. 0.89. What is the ratio of the Number of teachers in Czech Republic in 1998 to that in 2007?
Provide a succinct answer. 1.52. What is the ratio of the Number of teachers in Middle income in 1998 to that in 2010?
Make the answer very short. 0.88. What is the ratio of the Number of teachers of Angola in 1998 to that in 2010?
Your response must be concise. 0.34. What is the ratio of the Number of teachers in Cambodia in 1998 to that in 2010?
Provide a succinct answer. 0.92. What is the ratio of the Number of teachers in Czech Republic in 1998 to that in 2010?
Your response must be concise. 1.51. What is the ratio of the Number of teachers in Middle income in 2007 to that in 2010?
Keep it short and to the point. 0.96. What is the ratio of the Number of teachers in Angola in 2007 to that in 2010?
Offer a very short reply. 0.93. What is the ratio of the Number of teachers of Cambodia in 2007 to that in 2010?
Provide a short and direct response. 1.04. What is the difference between the highest and the second highest Number of teachers of Middle income?
Your answer should be compact. 7.15e+05. What is the difference between the highest and the second highest Number of teachers of Angola?
Offer a terse response. 6965. What is the difference between the highest and the second highest Number of teachers of Cambodia?
Provide a succinct answer. 1831. What is the difference between the highest and the second highest Number of teachers in Czech Republic?
Offer a very short reply. 1.27e+04. What is the difference between the highest and the lowest Number of teachers of Middle income?
Keep it short and to the point. 5.43e+06. What is the difference between the highest and the lowest Number of teachers of Angola?
Provide a short and direct response. 6.34e+04. What is the difference between the highest and the lowest Number of teachers of Cambodia?
Make the answer very short. 1.20e+04. What is the difference between the highest and the lowest Number of teachers of Czech Republic?
Make the answer very short. 1.60e+04. 